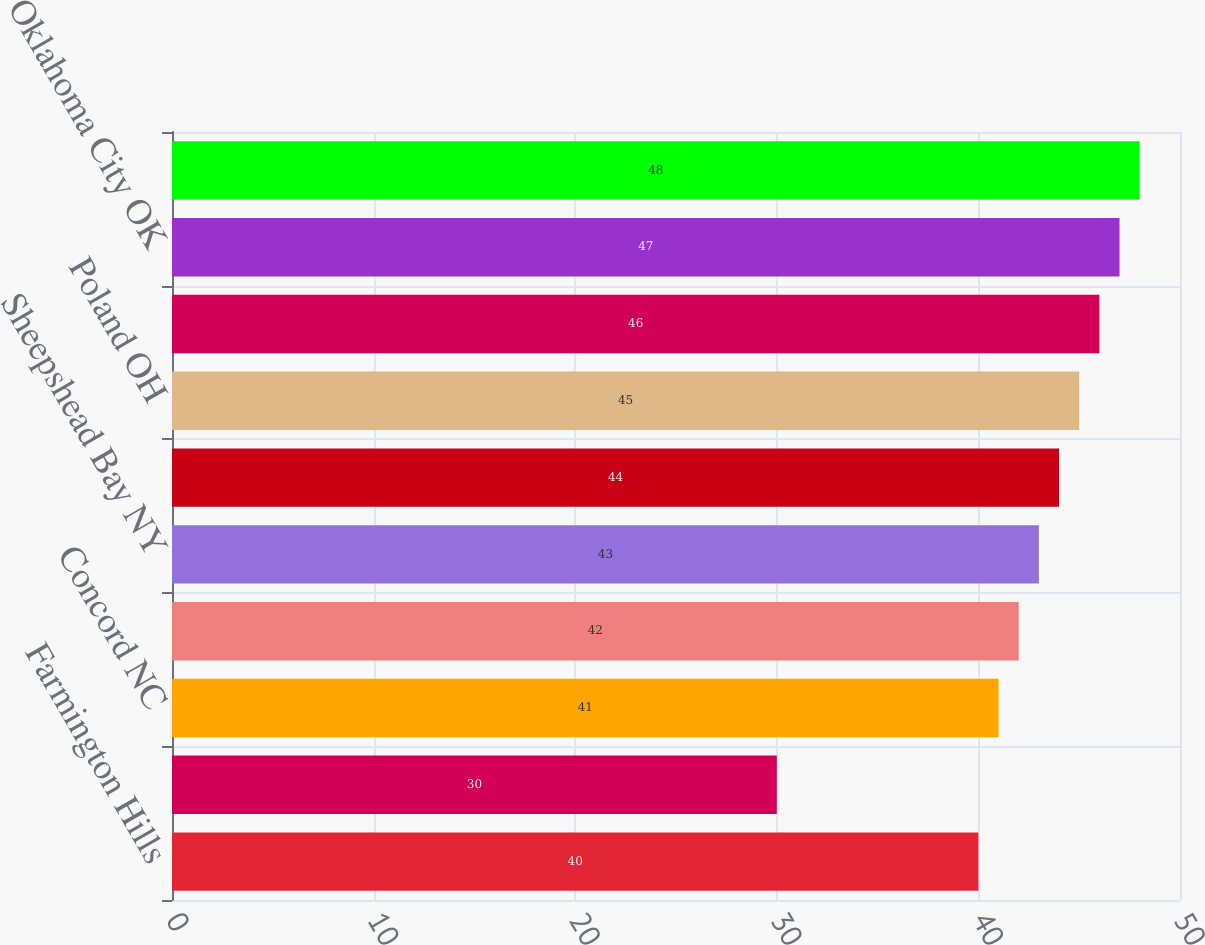<chart> <loc_0><loc_0><loc_500><loc_500><bar_chart><fcel>Farmington Hills<fcel>St Louis MO<fcel>Concord NC<fcel>Raleigh NC<fcel>Sheepshead Bay NY<fcel>Marietta OH<fcel>Poland OH<fcel>Willoughby OH<fcel>Oklahoma City OK<fcel>Greenville SC<nl><fcel>40<fcel>30<fcel>41<fcel>42<fcel>43<fcel>44<fcel>45<fcel>46<fcel>47<fcel>48<nl></chart> 